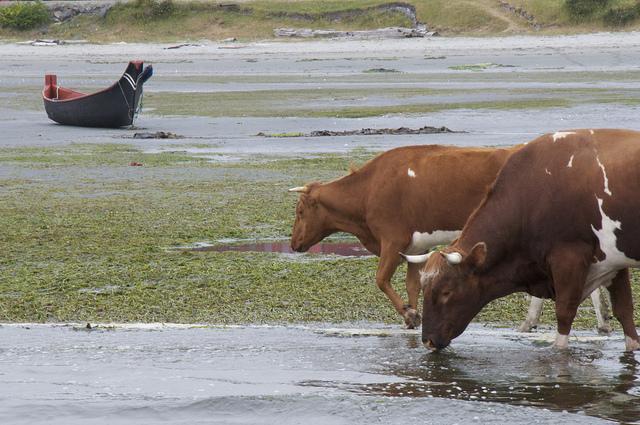Is this a seashore?
Write a very short answer. No. What color are the cows?
Quick response, please. Brown. Is one of the cows drinking?
Answer briefly. Yes. 